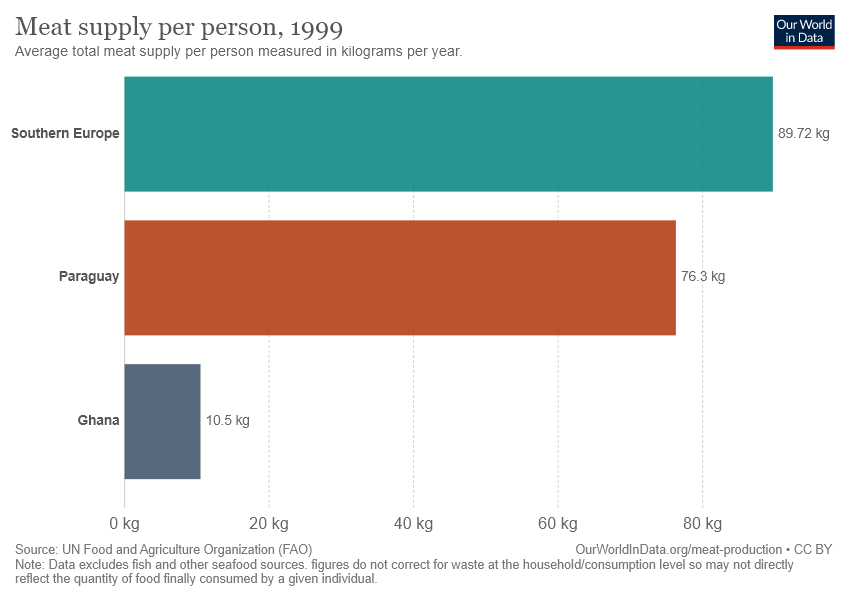What source is the data from? The data presented in the image is sourced from the UN Food and Agriculture Organization (FAO). It is important to note sources to assess the credibility and methodology behind the data collection, which in turn can influence the interpretation of the data. 